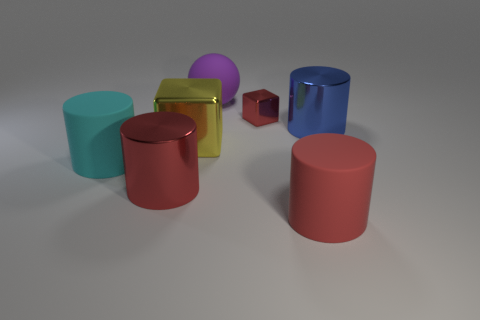Imagine these objects were used in a teaching setting; what concepts could they help illustrate? In a teaching setting, these objects could serve as effective visual aids for lessons in geometry, allowing students to understand and differentiate between forms such as cylinders, cuboids, spheres, and cubes. Additionally, they could be useful in explaining the fundamentals of perspective, light and shadow, and color theory, particularly in the context of art and design education. 